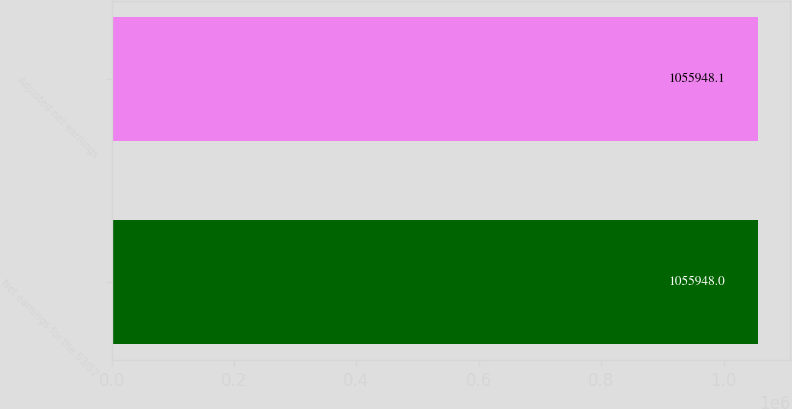<chart> <loc_0><loc_0><loc_500><loc_500><bar_chart><fcel>Net earnings for the 53/52<fcel>Adjusted net earnings<nl><fcel>1.05595e+06<fcel>1.05595e+06<nl></chart> 